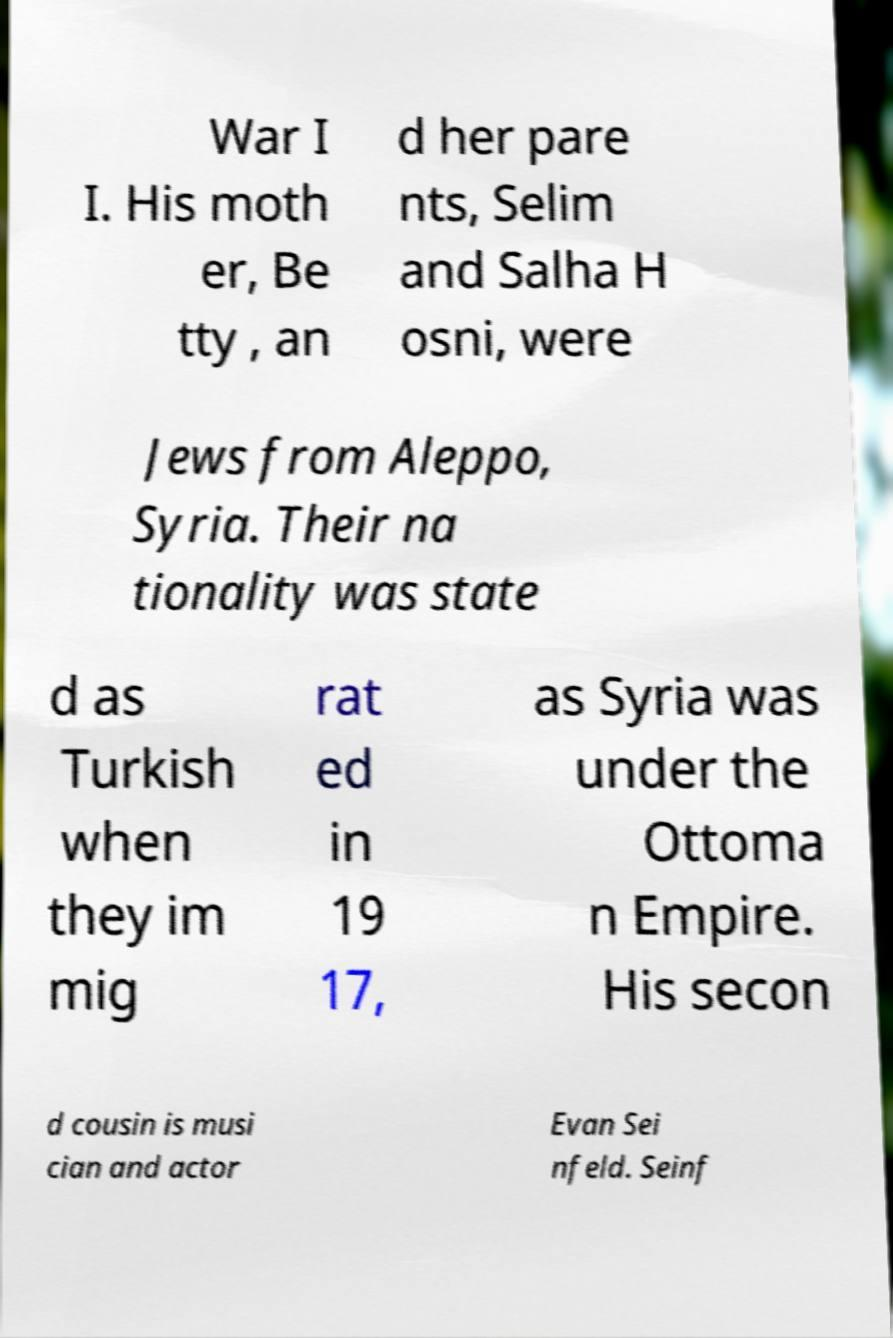What messages or text are displayed in this image? I need them in a readable, typed format. War I I. His moth er, Be tty , an d her pare nts, Selim and Salha H osni, were Jews from Aleppo, Syria. Their na tionality was state d as Turkish when they im mig rat ed in 19 17, as Syria was under the Ottoma n Empire. His secon d cousin is musi cian and actor Evan Sei nfeld. Seinf 